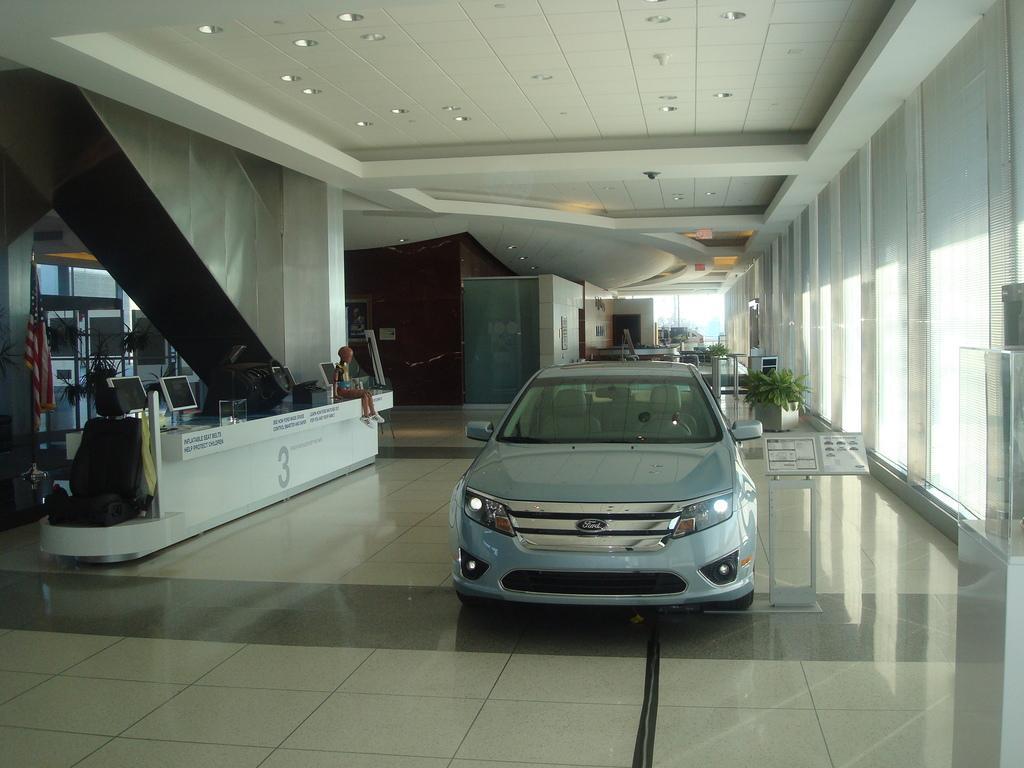Can you describe this image briefly? In this picture we can see a car on the floor, monitors, seat, house plants, stand, robot and in the background we can see wall with a poster. 